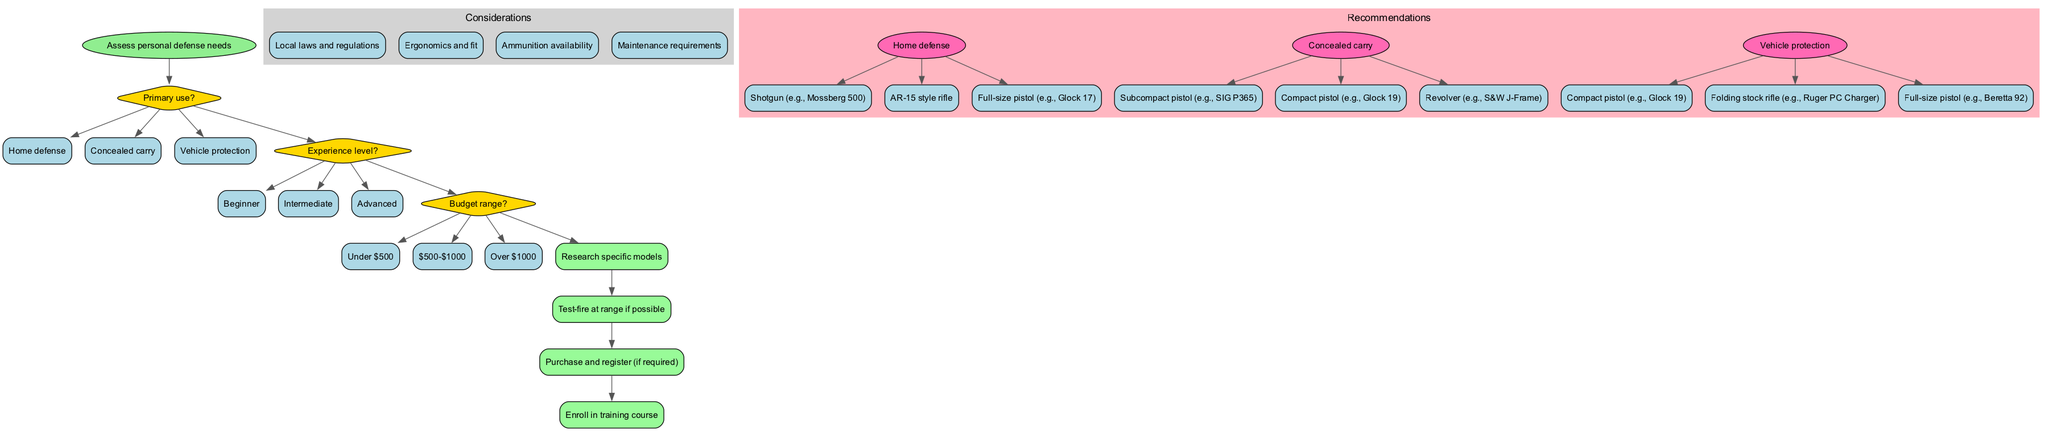What is the starting point of the decision-making process? The diagram indicates that the starting point of the decision-making process is "Assess personal defense needs." This is represented by the initial node in the flow chart before any decisions are made.
Answer: Assess personal defense needs How many primary use options are there? The diagram lists three distinct options under the primary use question: "Home defense," "Concealed carry," and "Vehicle protection." Counting these options gives a total of three.
Answer: 3 What is the first consideration listed in the diagram? According to the diagram's structure, the considerations are displayed in a cluster after the decision nodes. The first consideration mentioned is "Local laws and regulations."
Answer: Local laws and regulations If the experience level is set to "Beginner," which category of weapons can be recommended for home defense? In the flow of the diagram, selecting "Home defense" after choosing "Beginner" leads you to recommendations for weapons. The recommendations for home defense include "Shotgun (e.g., Mossberg 500)," irrespective of experience level, but fitting a beginner. Thus, the weapons remain constant.
Answer: Shotgun (e.g., Mossberg 500) What is the relationship between budget range and personal defense weapon recommendations? The budget range decision allows individuals to filter their options based on financial capacity. The recommendations for weapons vary significantly based on this budget, but detailed connection isn't shown in the diagram; it simply categorizes choices under budgets without causing a direct impact in this representation.
Answer: Variability of recommendations Which final step immediately follows "Purchase and register (if required)"? The diagram outlines a sequence of final steps. After "Purchase and register (if required)," the next immediate step is "Enroll in training course." Traversing down this part of the flow chart provides the answer.
Answer: Enroll in training course How many decisions are part of the process before reaching recommendations? There are three decisions depicted in the diagram: "Primary use," "Experience level," and "Budget range." Counting these leads to a conclusion that the process includes three decision nodes before reaching the recommendations.
Answer: 3 Which weapon is recommended for concealed carry that has a specific model mentioned? Reviewing the recommendations for the concealed carry category, one specific model mentioned is the "Subcompact pistol (e.g., SIG P365)." This is explicitly stated in the recommendations and highlights a particular choice for that purpose.
Answer: Subcompact pistol (e.g., SIG P365) 